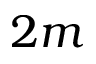<formula> <loc_0><loc_0><loc_500><loc_500>2 m</formula> 